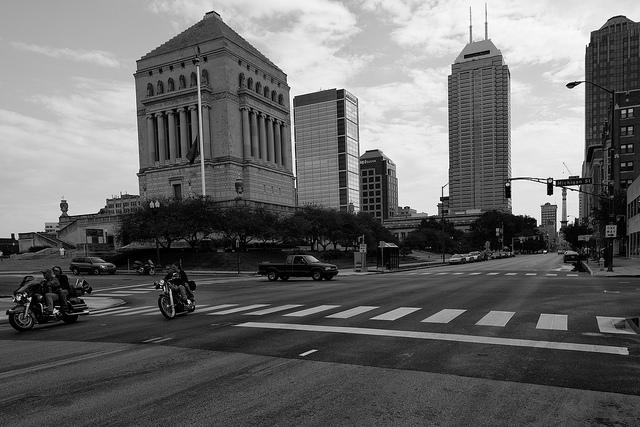What did the motorcycle near the crosswalk just do? turn 